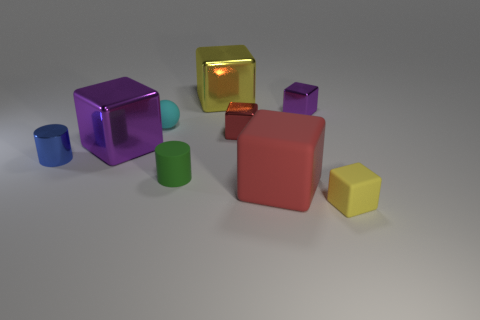Subtract all yellow blocks. How many blocks are left? 4 Subtract all small yellow cubes. How many cubes are left? 5 Subtract all green blocks. Subtract all red cylinders. How many blocks are left? 6 Add 1 tiny blue things. How many objects exist? 10 Subtract all cylinders. How many objects are left? 7 Add 3 purple cubes. How many purple cubes exist? 5 Subtract 0 brown balls. How many objects are left? 9 Subtract all tiny cylinders. Subtract all big red matte blocks. How many objects are left? 6 Add 9 large matte objects. How many large matte objects are left? 10 